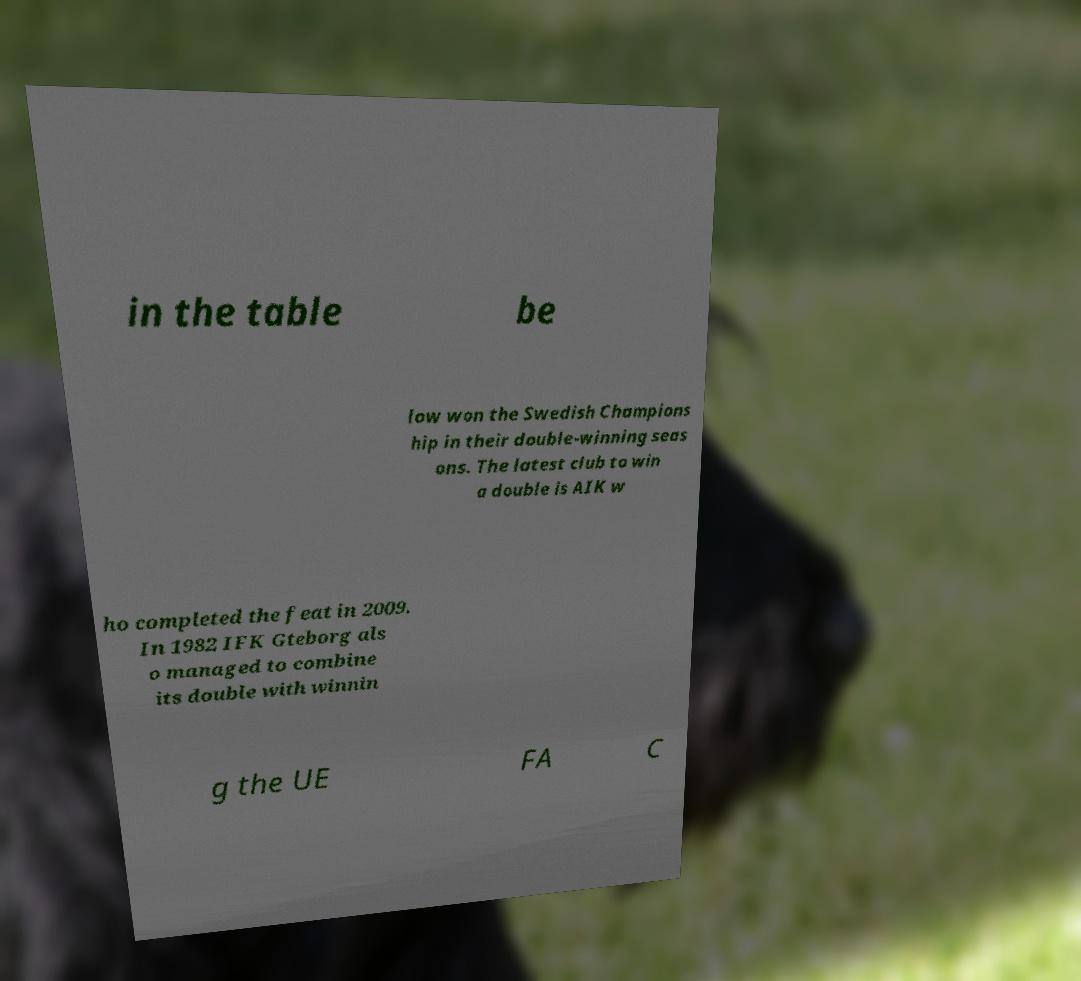Could you extract and type out the text from this image? in the table be low won the Swedish Champions hip in their double-winning seas ons. The latest club to win a double is AIK w ho completed the feat in 2009. In 1982 IFK Gteborg als o managed to combine its double with winnin g the UE FA C 